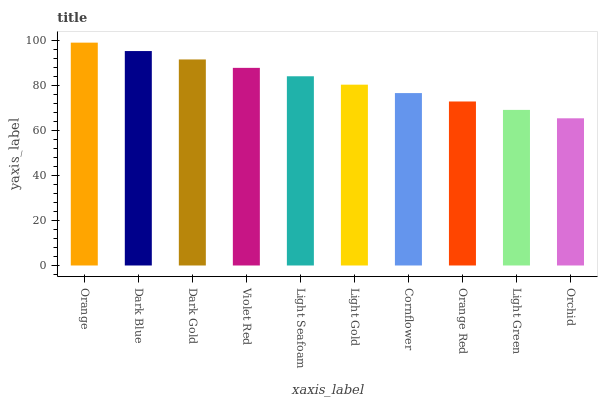Is Orchid the minimum?
Answer yes or no. Yes. Is Orange the maximum?
Answer yes or no. Yes. Is Dark Blue the minimum?
Answer yes or no. No. Is Dark Blue the maximum?
Answer yes or no. No. Is Orange greater than Dark Blue?
Answer yes or no. Yes. Is Dark Blue less than Orange?
Answer yes or no. Yes. Is Dark Blue greater than Orange?
Answer yes or no. No. Is Orange less than Dark Blue?
Answer yes or no. No. Is Light Seafoam the high median?
Answer yes or no. Yes. Is Light Gold the low median?
Answer yes or no. Yes. Is Orange the high median?
Answer yes or no. No. Is Cornflower the low median?
Answer yes or no. No. 